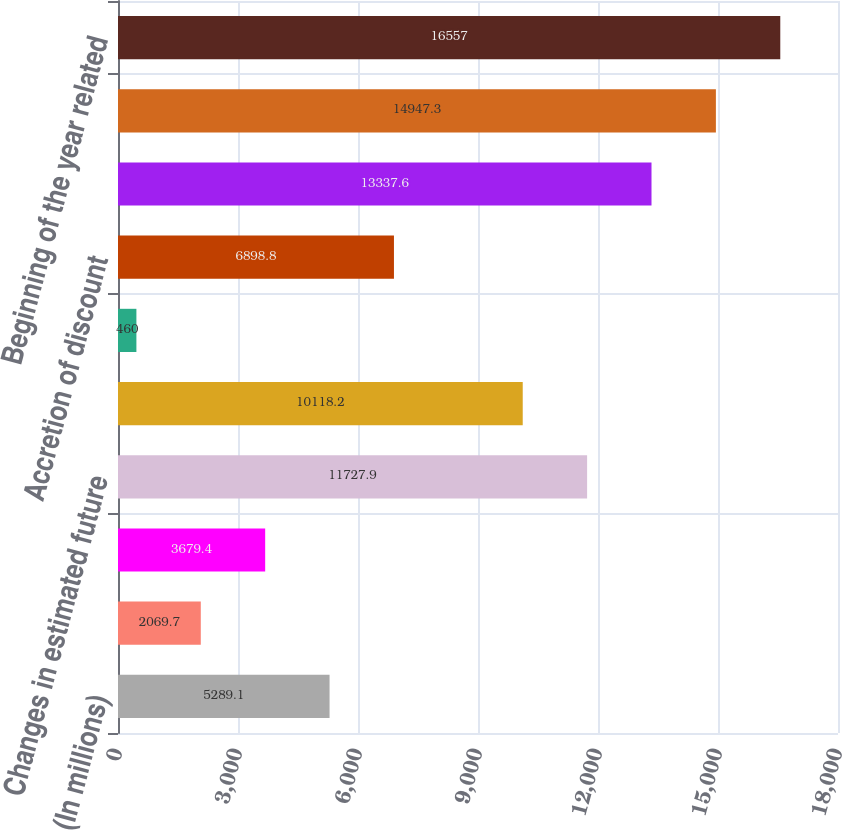Convert chart to OTSL. <chart><loc_0><loc_0><loc_500><loc_500><bar_chart><fcel>(In millions)<fcel>Extensions discoveries and<fcel>Development costs incurred<fcel>Changes in estimated future<fcel>Revisions of previous quantity<fcel>Net changes in purchases and<fcel>Accretion of discount<fcel>Net change in income taxes<fcel>Net change for the year<fcel>Beginning of the year related<nl><fcel>5289.1<fcel>2069.7<fcel>3679.4<fcel>11727.9<fcel>10118.2<fcel>460<fcel>6898.8<fcel>13337.6<fcel>14947.3<fcel>16557<nl></chart> 